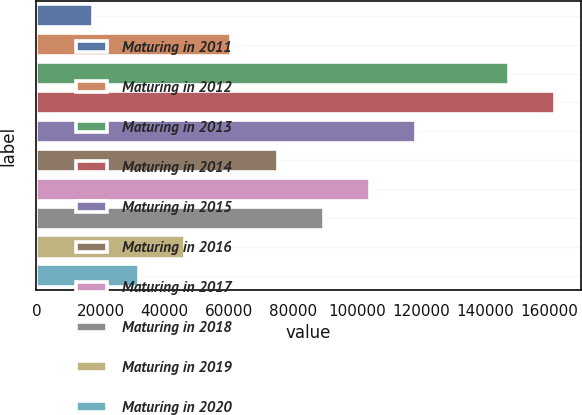Convert chart. <chart><loc_0><loc_0><loc_500><loc_500><bar_chart><fcel>Maturing in 2011<fcel>Maturing in 2012<fcel>Maturing in 2013<fcel>Maturing in 2014<fcel>Maturing in 2015<fcel>Maturing in 2016<fcel>Maturing in 2017<fcel>Maturing in 2018<fcel>Maturing in 2019<fcel>Maturing in 2020<nl><fcel>17575<fcel>60862<fcel>147436<fcel>161865<fcel>118578<fcel>75291<fcel>104149<fcel>89720<fcel>46433<fcel>32004<nl></chart> 